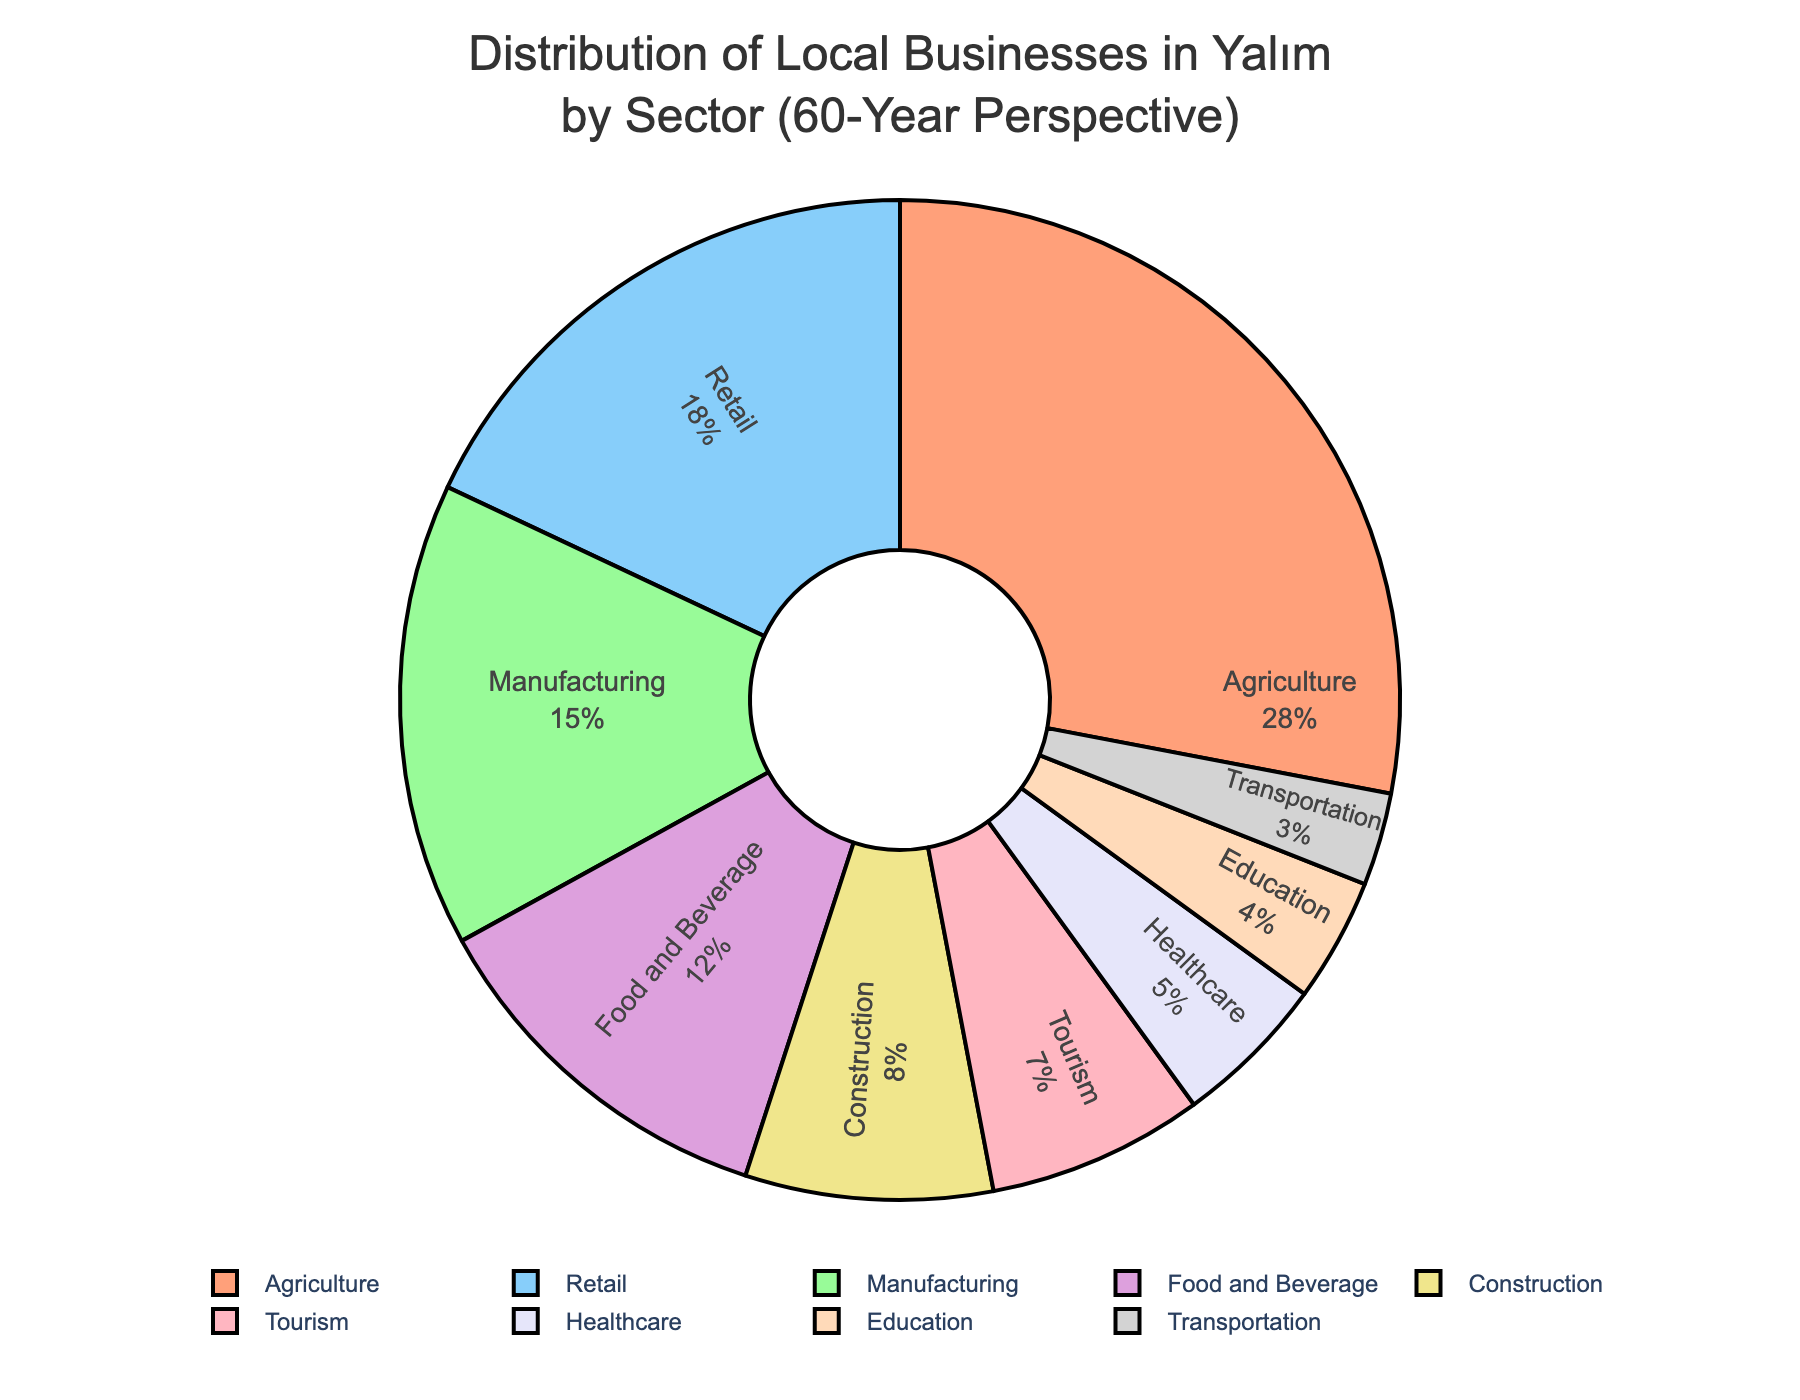Which sector has the largest proportion of local businesses? The pie chart shows that Agriculture has the largest segment, occupying the biggest area of all sectors.
Answer: Agriculture What is the combined percentage of local businesses in Retail and Food and Beverage? The percentage for Retail is 18% and for Food and Beverage is 12%. Adding them together, 18 + 12 = 30.
Answer: 30% How does the proportion of Tourism businesses compare to Healthcare businesses? The pie chart shows that Tourism accounts for 7% while Healthcare accounts for 5%. Since 7% is greater than 5%, Tourism has a higher proportion than Healthcare.
Answer: Tourism has a higher proportion Which sector has a smaller percentage of local businesses, Education or Transportation? The pie chart shows that Education accounts for 4% while Transportation accounts for 3%. Since 3% is less than 4%, Transportation has a smaller percentage.
Answer: Transportation What percentage of local businesses come from sectors other than Agriculture and Manufacturing? Agriculture has 28% and Manufacturing has 15%. Adding these together gives 28 + 15 = 43%. Subtracting this from 100% gives 100 - 43 = 57%.
Answer: 57% Which three sectors have the smallest proportion of local businesses, and what is their total percentage? According to the pie chart, the three smallest sectors are Healthcare (5%), Education (4%), and Transportation (3%). Adding these together, 5 + 4 + 3 = 12%.
Answer: Healthcare, Education, Transportation (12%) Which sector has exactly half the proportion of Food and Beverage businesses? Food and Beverage has 12%. The sector with exactly half of this is 12 / 2 = 6%. Looking at the pie chart, no sector has exactly 6%, so the question cannot be answered directly from the figure without approximation.
Answer: None What is the difference in percentage between the Manufacturing and Construction sectors? Manufacturing has 15% and Construction has 8%. The difference is 15 - 8 = 7%.
Answer: 7% What sectors make up over a quarter of the local businesses in Yalım combined? The pie chart shows that Agriculture alone occupies 28%, which is more than a quarter (25%) of the local businesses.
Answer: Agriculture 